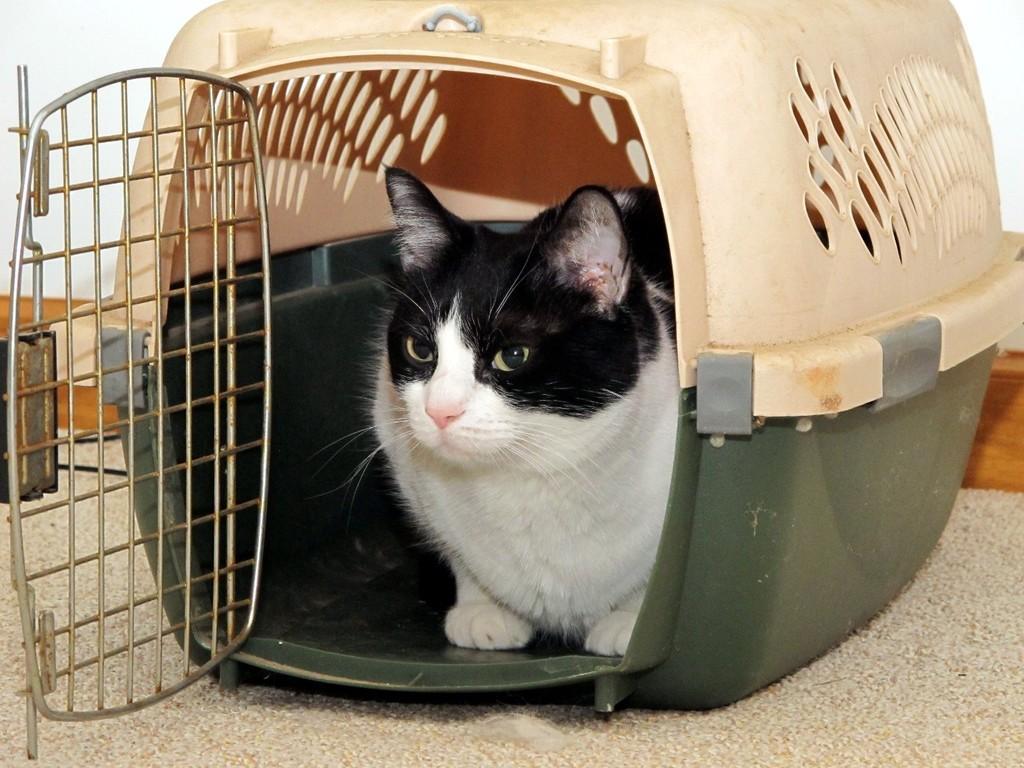Please provide a concise description of this image. In the picture I can see a cat is sitting in a cage. The cage is on a surface. The background of the image is white in color. 